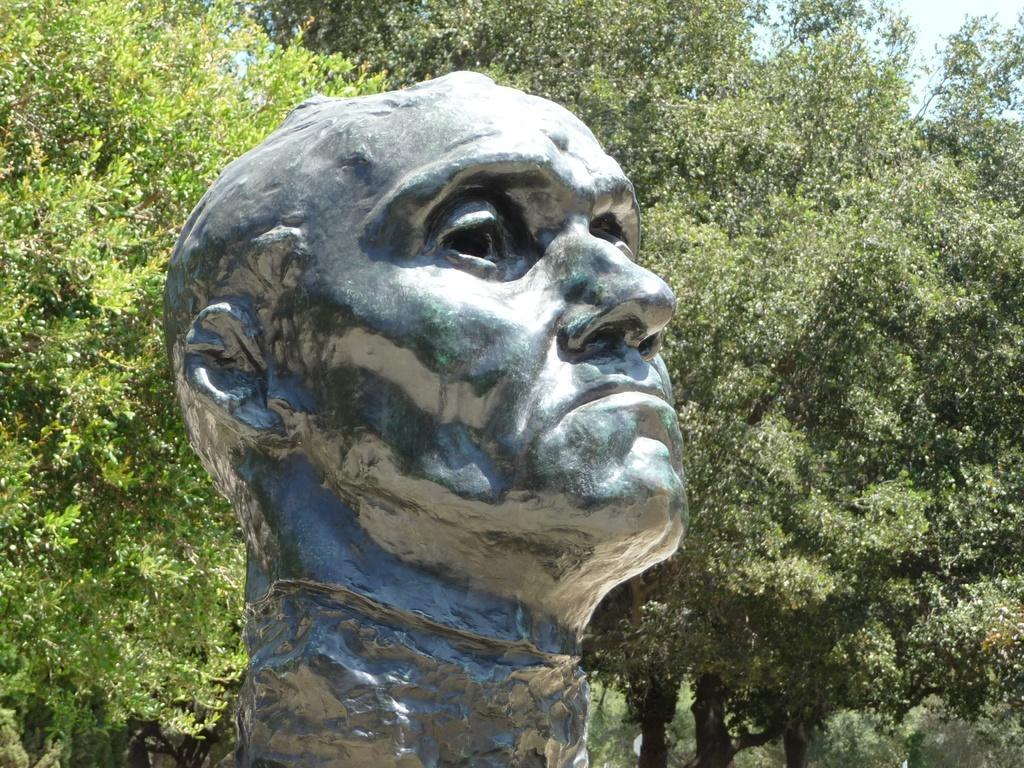Describe this image in one or two sentences. In the middle of the image we can see a statue. Behind the statue there are some trees. In the top right corner there is sky. 